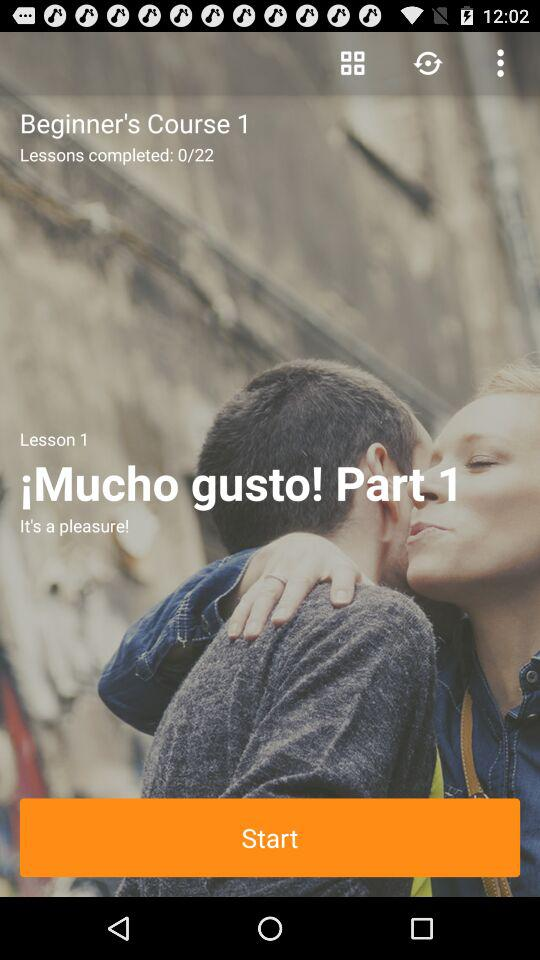How many lessons in total are there in the course? There are 22 lessons in the course. 